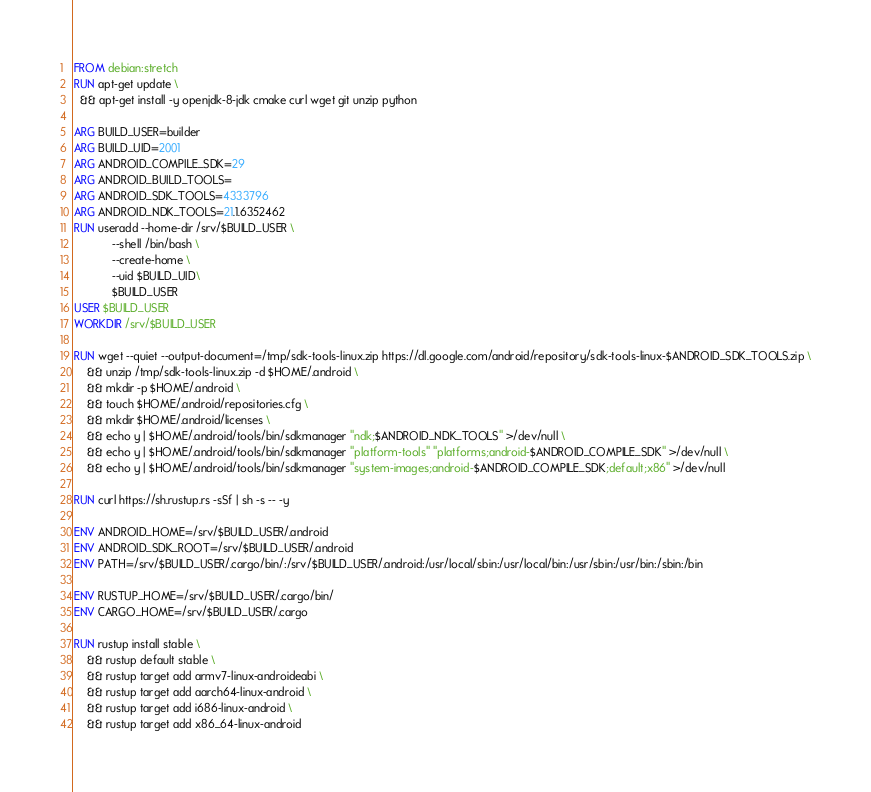<code> <loc_0><loc_0><loc_500><loc_500><_Dockerfile_>FROM debian:stretch
RUN apt-get update \
  && apt-get install -y openjdk-8-jdk cmake curl wget git unzip python

ARG BUILD_USER=builder
ARG BUILD_UID=2001
ARG ANDROID_COMPILE_SDK=29
ARG ANDROID_BUILD_TOOLS=
ARG ANDROID_SDK_TOOLS=4333796 
ARG ANDROID_NDK_TOOLS=21.1.6352462
RUN useradd --home-dir /srv/$BUILD_USER \
            --shell /bin/bash \
            --create-home \
            --uid $BUILD_UID\
            $BUILD_USER
USER $BUILD_USER
WORKDIR /srv/$BUILD_USER

RUN wget --quiet --output-document=/tmp/sdk-tools-linux.zip https://dl.google.com/android/repository/sdk-tools-linux-$ANDROID_SDK_TOOLS.zip \
    && unzip /tmp/sdk-tools-linux.zip -d $HOME/.android \
    && mkdir -p $HOME/.android \ 
    && touch $HOME/.android/repositories.cfg \
    && mkdir $HOME/.android/licenses \
    && echo y | $HOME/.android/tools/bin/sdkmanager "ndk;$ANDROID_NDK_TOOLS" >/dev/null \
    && echo y | $HOME/.android/tools/bin/sdkmanager "platform-tools" "platforms;android-$ANDROID_COMPILE_SDK" >/dev/null \
    && echo y | $HOME/.android/tools/bin/sdkmanager "system-images;android-$ANDROID_COMPILE_SDK;default;x86" >/dev/null 

RUN curl https://sh.rustup.rs -sSf | sh -s -- -y

ENV ANDROID_HOME=/srv/$BUILD_USER/.android
ENV ANDROID_SDK_ROOT=/srv/$BUILD_USER/.android
ENV PATH=/srv/$BUILD_USER/.cargo/bin/:/srv/$BUILD_USER/.android:/usr/local/sbin:/usr/local/bin:/usr/sbin:/usr/bin:/sbin:/bin

ENV RUSTUP_HOME=/srv/$BUILD_USER/.cargo/bin/
ENV CARGO_HOME=/srv/$BUILD_USER/.cargo

RUN rustup install stable \
    && rustup default stable \
    && rustup target add armv7-linux-androideabi \
    && rustup target add aarch64-linux-android \
    && rustup target add i686-linux-android \
    && rustup target add x86_64-linux-android
</code> 